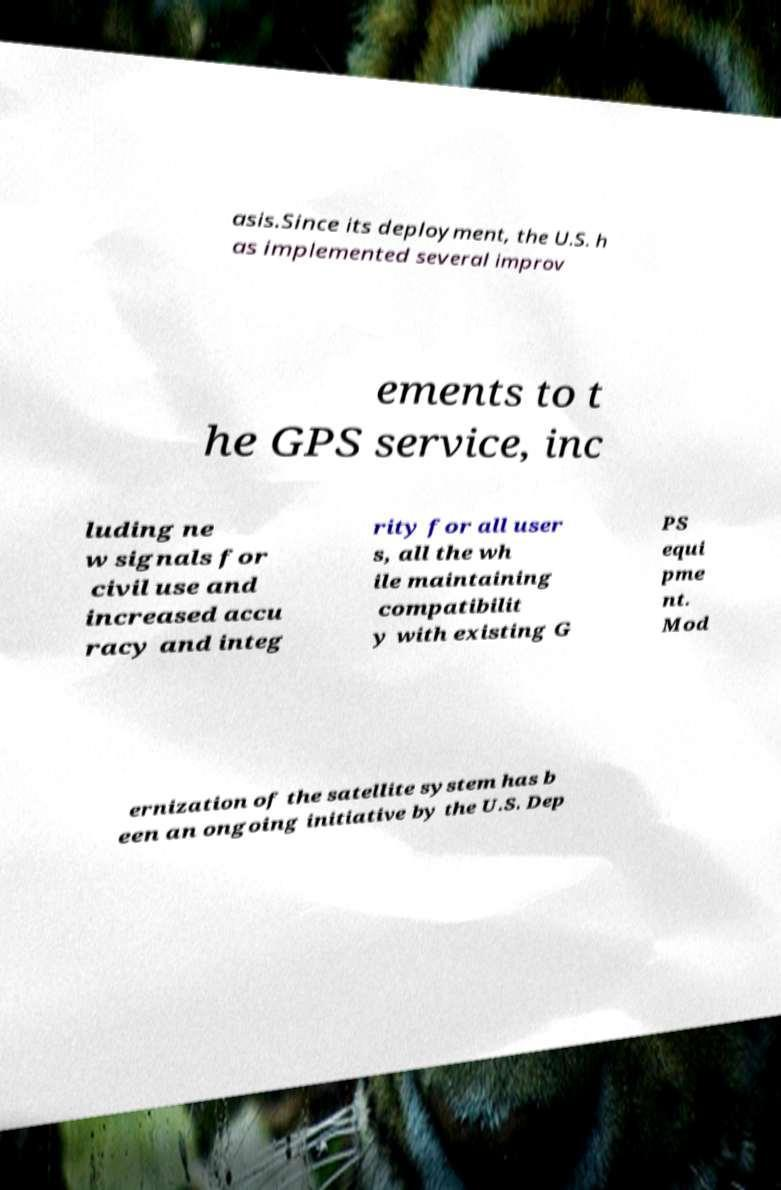Can you read and provide the text displayed in the image?This photo seems to have some interesting text. Can you extract and type it out for me? asis.Since its deployment, the U.S. h as implemented several improv ements to t he GPS service, inc luding ne w signals for civil use and increased accu racy and integ rity for all user s, all the wh ile maintaining compatibilit y with existing G PS equi pme nt. Mod ernization of the satellite system has b een an ongoing initiative by the U.S. Dep 